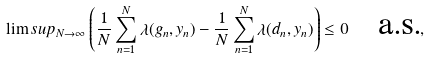Convert formula to latex. <formula><loc_0><loc_0><loc_500><loc_500>\lim s u p _ { N \to \infty } \left ( \frac { 1 } { N } \sum _ { n = 1 } ^ { N } \lambda ( g _ { n } , y _ { n } ) - \frac { 1 } { N } \sum _ { n = 1 } ^ { N } \lambda ( d _ { n } , y _ { n } ) \right ) \leq 0 \quad \text {a.s.} ,</formula> 